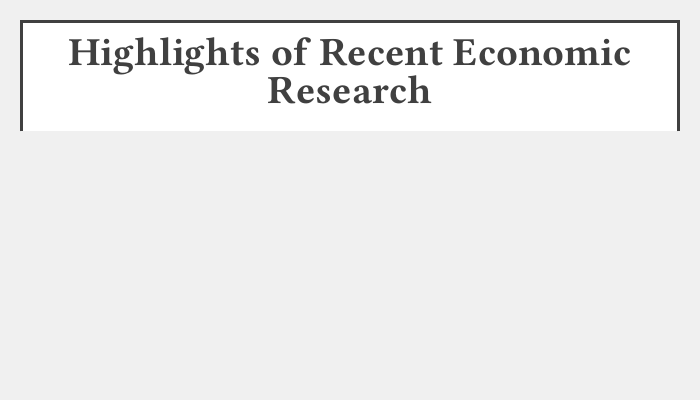What is the focus of the first highlighted research? The first highlighted research addresses behavioral implications in financial markets.
Answer: Behavioral Implications in Financial Markets What do traditional models predict regarding labor markets? The document states that traditional models predict trends without behavioral assumptions.
Answer: Predict trends without behavioral assumptions What drives consumer choices according to the document? The document emphasizes that price mechanisms drive choices, challenging psychological context.
Answer: Price mechanisms What ensures macroeconomic stability as per the highlights? Classical fiscal interventions are stated as ensuring stability in macroeconomics.
Answer: Classical fiscal interventions What principle holds in emerging economies, according to the document? The highlights confirm that efficiency principles hold with negligible behavioral effects in emerging economies.
Answer: Efficiency principles How many main highlights are presented in the document? The document lists five main highlights of recent economic research.
Answer: Five What term is used to describe the implications of market efficiency? The document refers to the implications in emerging economies as negligible behavioral effects.
Answer: Negligible behavioral effects What type of font is used in this document? The font specified in the document is Libertinus Serif.
Answer: Libertinus Serif 